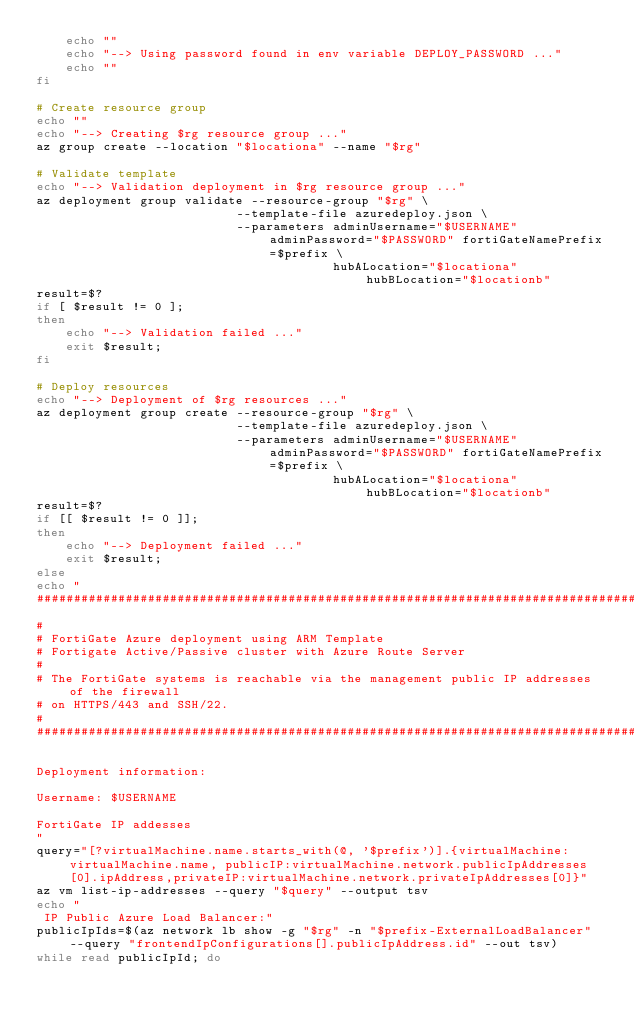Convert code to text. <code><loc_0><loc_0><loc_500><loc_500><_Bash_>    echo ""
    echo "--> Using password found in env variable DEPLOY_PASSWORD ..."
    echo ""
fi

# Create resource group
echo ""
echo "--> Creating $rg resource group ..."
az group create --location "$locationa" --name "$rg"

# Validate template
echo "--> Validation deployment in $rg resource group ..."
az deployment group validate --resource-group "$rg" \
                           --template-file azuredeploy.json \
                           --parameters adminUsername="$USERNAME" adminPassword="$PASSWORD" fortiGateNamePrefix=$prefix \
                                        hubALocation="$locationa" hubBLocation="$locationb"
result=$?
if [ $result != 0 ];
then
    echo "--> Validation failed ..."
    exit $result;
fi

# Deploy resources
echo "--> Deployment of $rg resources ..."
az deployment group create --resource-group "$rg" \
                           --template-file azuredeploy.json \
                           --parameters adminUsername="$USERNAME" adminPassword="$PASSWORD" fortiGateNamePrefix=$prefix \
                                        hubALocation="$locationa" hubBLocation="$locationb"
result=$?
if [[ $result != 0 ]];
then
    echo "--> Deployment failed ..."
    exit $result;
else
echo "
##############################################################################################################
#
# FortiGate Azure deployment using ARM Template
# Fortigate Active/Passive cluster with Azure Route Server
#
# The FortiGate systems is reachable via the management public IP addresses of the firewall
# on HTTPS/443 and SSH/22.
#
##############################################################################################################

Deployment information:

Username: $USERNAME

FortiGate IP addesses
"
query="[?virtualMachine.name.starts_with(@, '$prefix')].{virtualMachine:virtualMachine.name, publicIP:virtualMachine.network.publicIpAddresses[0].ipAddress,privateIP:virtualMachine.network.privateIpAddresses[0]}"
az vm list-ip-addresses --query "$query" --output tsv
echo "
 IP Public Azure Load Balancer:"
publicIpIds=$(az network lb show -g "$rg" -n "$prefix-ExternalLoadBalancer" --query "frontendIpConfigurations[].publicIpAddress.id" --out tsv)
while read publicIpId; do</code> 